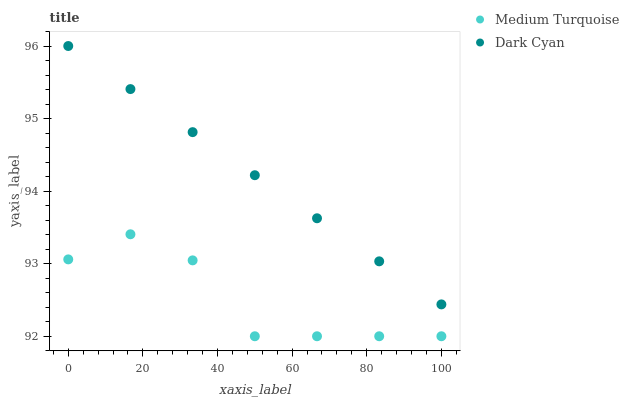Does Medium Turquoise have the minimum area under the curve?
Answer yes or no. Yes. Does Dark Cyan have the maximum area under the curve?
Answer yes or no. Yes. Does Medium Turquoise have the maximum area under the curve?
Answer yes or no. No. Is Dark Cyan the smoothest?
Answer yes or no. Yes. Is Medium Turquoise the roughest?
Answer yes or no. Yes. Is Medium Turquoise the smoothest?
Answer yes or no. No. Does Medium Turquoise have the lowest value?
Answer yes or no. Yes. Does Dark Cyan have the highest value?
Answer yes or no. Yes. Does Medium Turquoise have the highest value?
Answer yes or no. No. Is Medium Turquoise less than Dark Cyan?
Answer yes or no. Yes. Is Dark Cyan greater than Medium Turquoise?
Answer yes or no. Yes. Does Medium Turquoise intersect Dark Cyan?
Answer yes or no. No. 